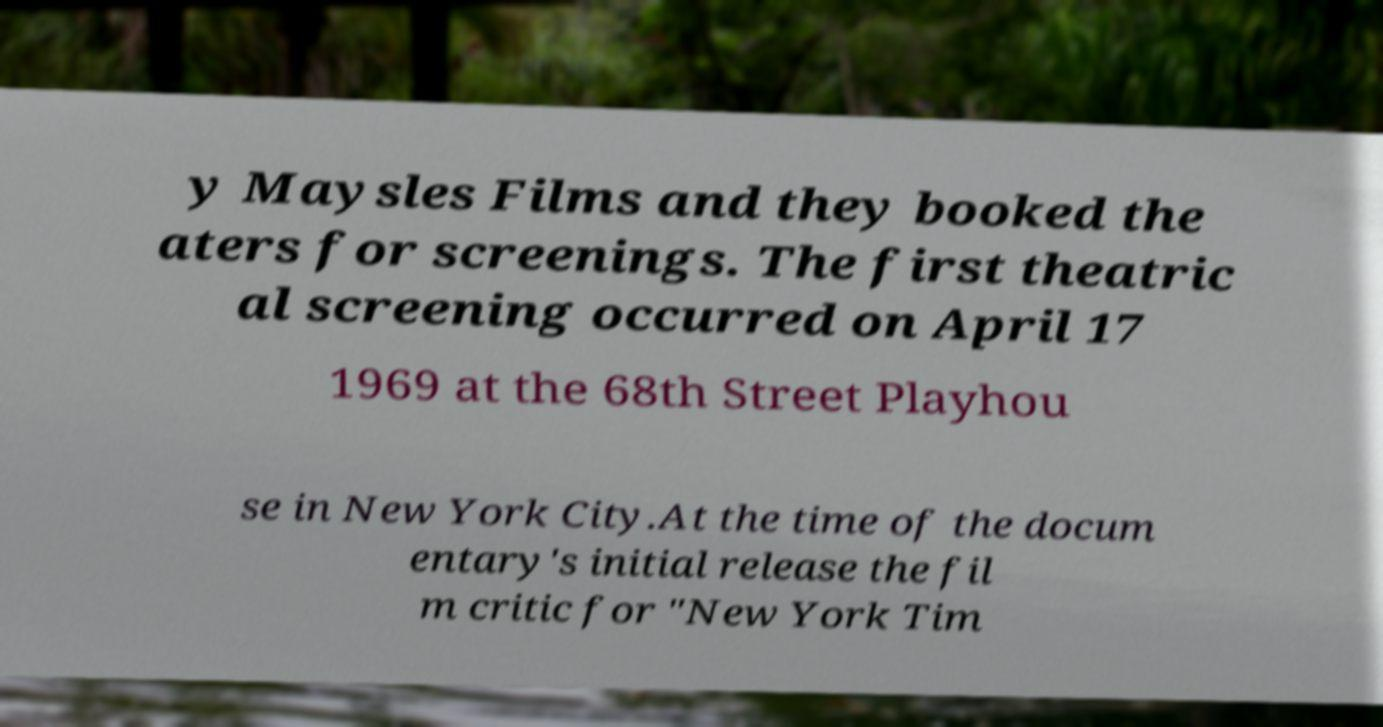Please read and relay the text visible in this image. What does it say? y Maysles Films and they booked the aters for screenings. The first theatric al screening occurred on April 17 1969 at the 68th Street Playhou se in New York City.At the time of the docum entary's initial release the fil m critic for "New York Tim 